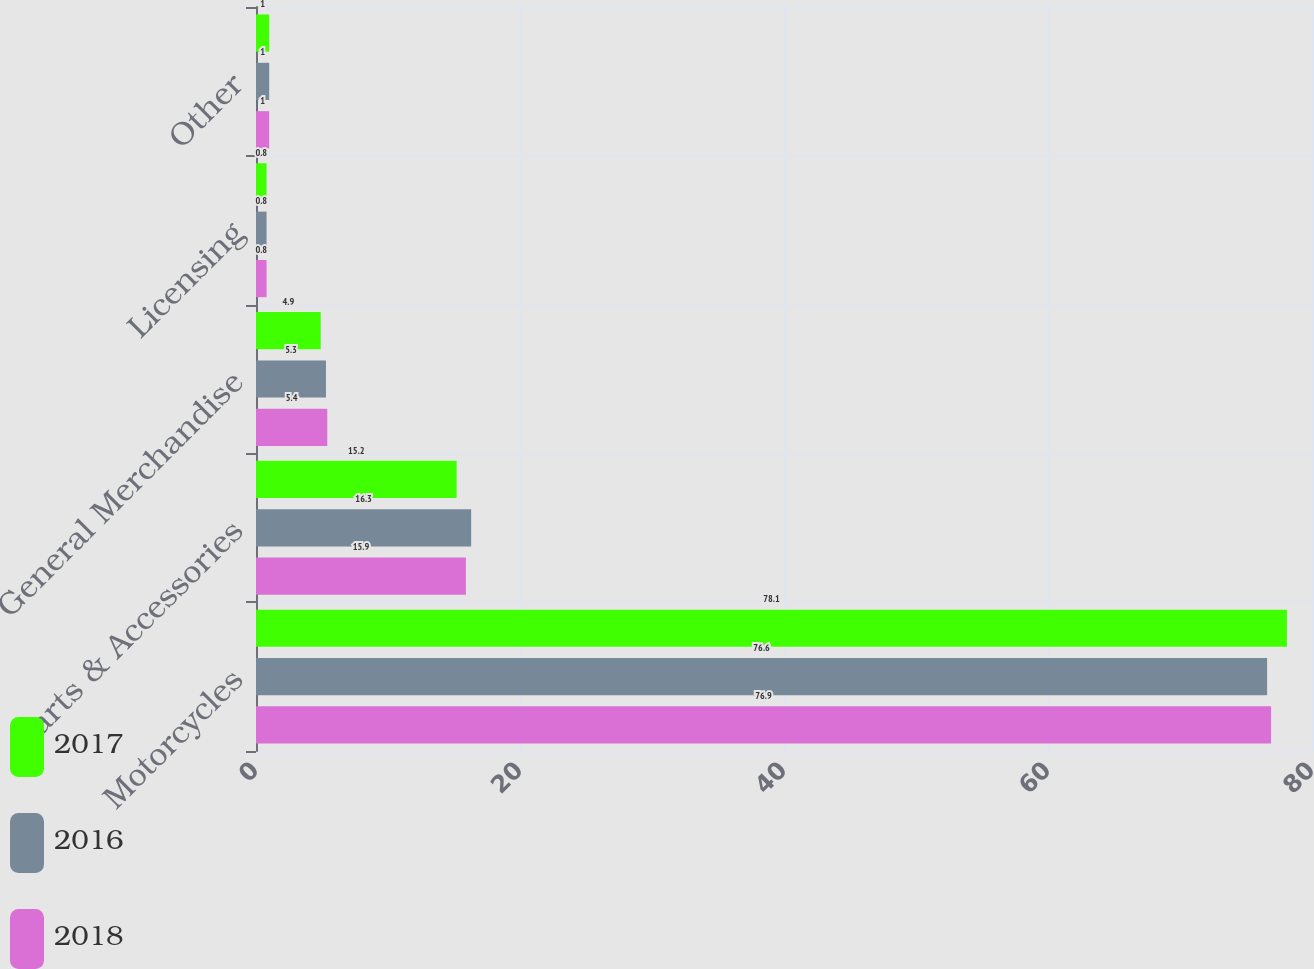Convert chart to OTSL. <chart><loc_0><loc_0><loc_500><loc_500><stacked_bar_chart><ecel><fcel>Motorcycles<fcel>Parts & Accessories<fcel>General Merchandise<fcel>Licensing<fcel>Other<nl><fcel>2017<fcel>78.1<fcel>15.2<fcel>4.9<fcel>0.8<fcel>1<nl><fcel>2016<fcel>76.6<fcel>16.3<fcel>5.3<fcel>0.8<fcel>1<nl><fcel>2018<fcel>76.9<fcel>15.9<fcel>5.4<fcel>0.8<fcel>1<nl></chart> 